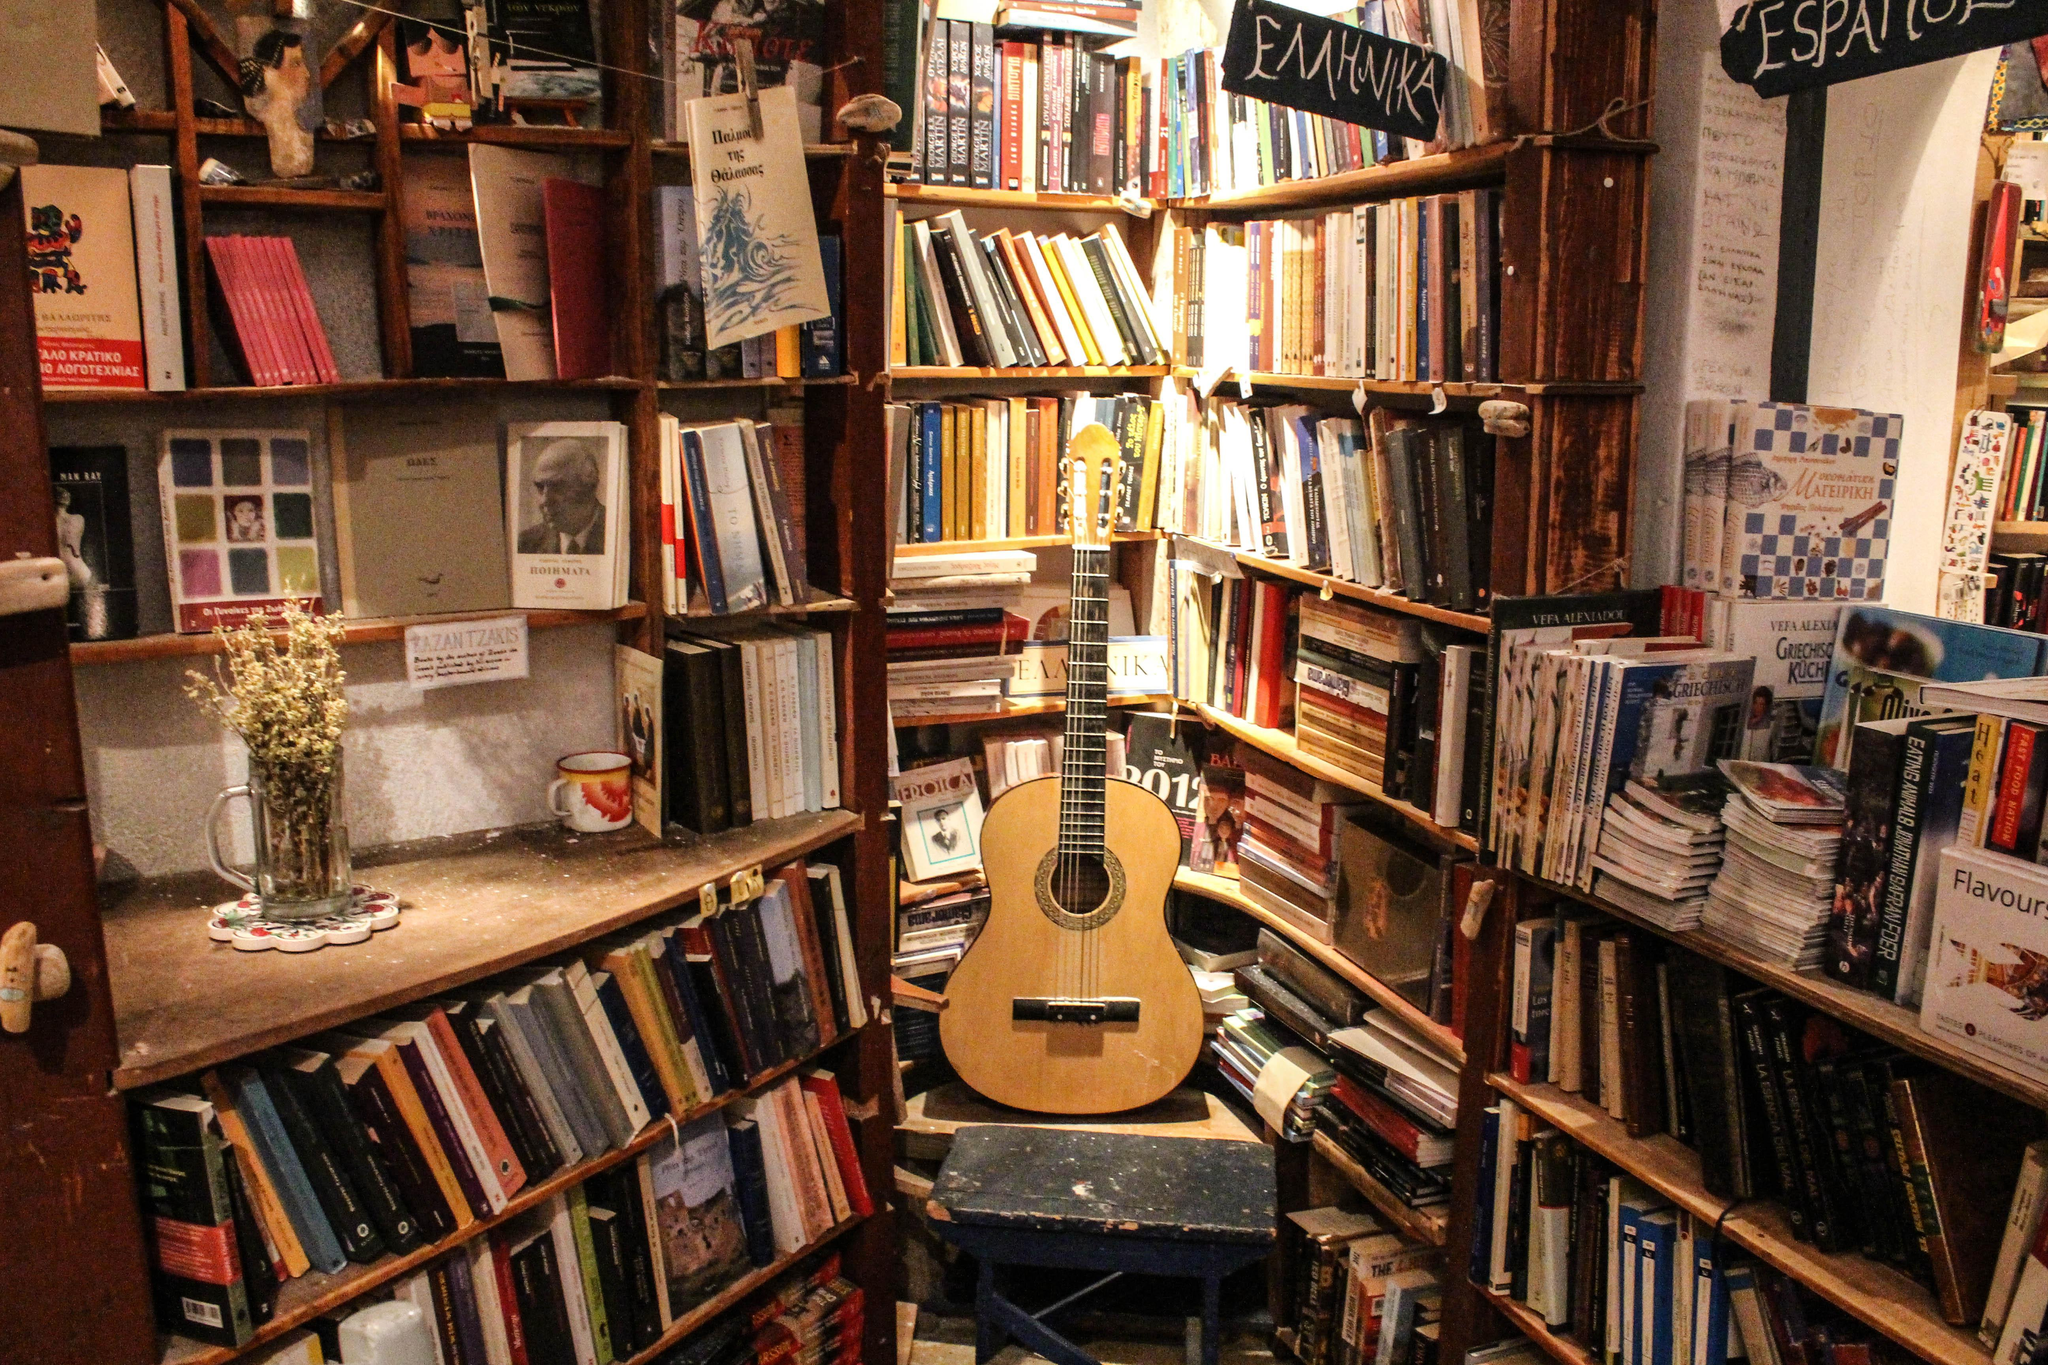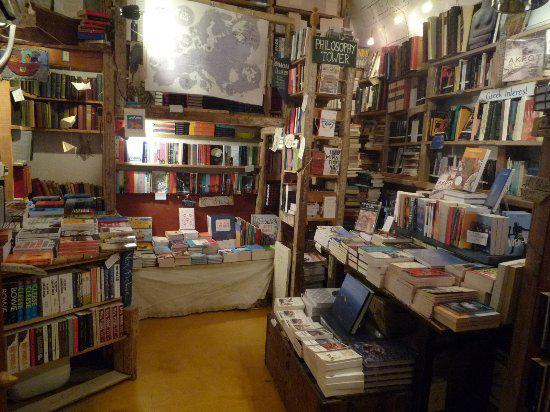The first image is the image on the left, the second image is the image on the right. Assess this claim about the two images: "An image of a room lined with shelves of books includes a stringed instrument near the center of the picture.". Correct or not? Answer yes or no. Yes. The first image is the image on the left, the second image is the image on the right. Examine the images to the left and right. Is the description "At least one person is near the bookstore in one of the images." accurate? Answer yes or no. No. 